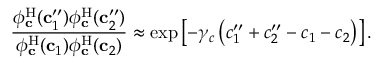<formula> <loc_0><loc_0><loc_500><loc_500>\frac { \phi _ { c } ^ { H } ( c _ { 1 } ^ { \prime \prime } ) \phi _ { c } ^ { H } ( c _ { 2 } ^ { \prime \prime } ) } { \phi _ { c } ^ { H } ( c _ { 1 } ) \phi _ { c } ^ { H } ( c _ { 2 } ) } \approx \exp \left [ - \gamma _ { c } \left ( c _ { 1 } ^ { \prime \prime } + c _ { 2 } ^ { \prime \prime } - c _ { 1 } - c _ { 2 } \right ) \right ] .</formula> 